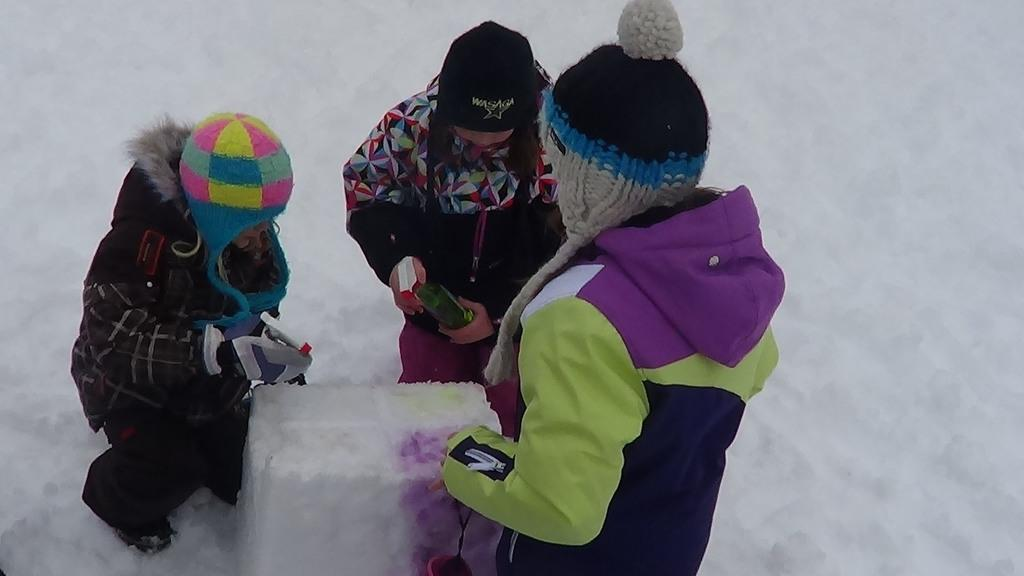How many people are present in the image? There are three people in the image. What position are the people in? The people are sitting on their knees. What is the setting of the image? The image is set on a snow land. What can be seen in the middle of the image? There is a snow cube in the middle of the image. What type of clock is hanging on the curtain in the image? There is no clock or curtain present in the image; it is set on a snow land with a snow cube in the middle. 